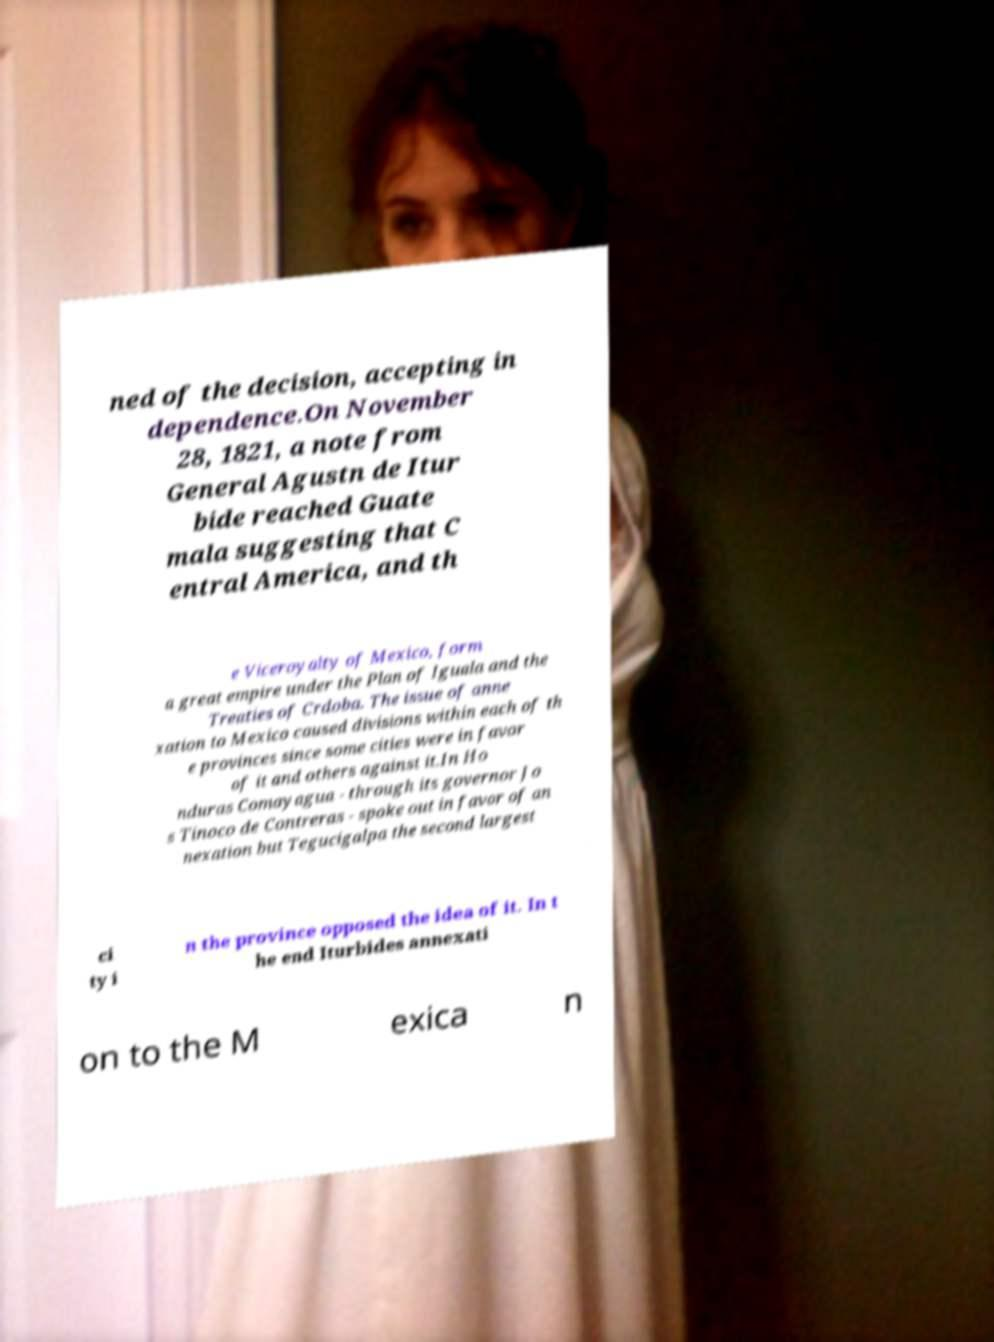Can you accurately transcribe the text from the provided image for me? ned of the decision, accepting in dependence.On November 28, 1821, a note from General Agustn de Itur bide reached Guate mala suggesting that C entral America, and th e Viceroyalty of Mexico, form a great empire under the Plan of Iguala and the Treaties of Crdoba. The issue of anne xation to Mexico caused divisions within each of th e provinces since some cities were in favor of it and others against it.In Ho nduras Comayagua - through its governor Jo s Tinoco de Contreras - spoke out in favor of an nexation but Tegucigalpa the second largest ci ty i n the province opposed the idea of it. In t he end Iturbides annexati on to the M exica n 